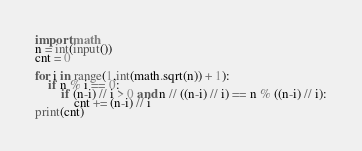Convert code to text. <code><loc_0><loc_0><loc_500><loc_500><_Python_>import math
n = int(input())
cnt = 0

for i in range(1,int(math.sqrt(n)) + 1):
    if n % i == 0:
        if (n-i) // i > 0 and n // ((n-i) // i) == n % ((n-i) // i):
            cnt += (n-i) // i
print(cnt)</code> 